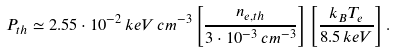<formula> <loc_0><loc_0><loc_500><loc_500>P _ { t h } \simeq 2 . 5 5 \cdot 1 0 ^ { - 2 } \, k e V \, c m ^ { - 3 } \left [ \frac { n _ { e , t h } } { 3 \cdot 1 0 ^ { - 3 } \, c m ^ { - 3 } } \right ] \left [ \frac { k _ { B } T _ { e } } { 8 . 5 \, k e V } \right ] .</formula> 